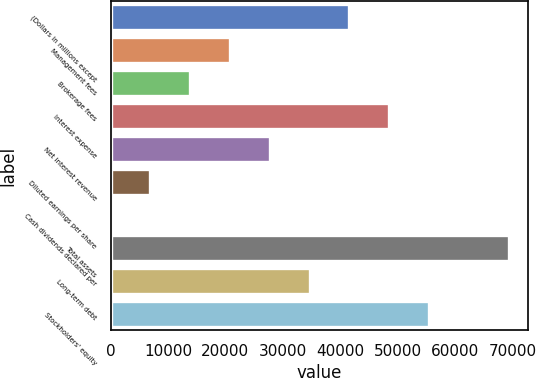<chart> <loc_0><loc_0><loc_500><loc_500><bar_chart><fcel>(Dollars in millions except<fcel>Management fees<fcel>Brokerage fees<fcel>Interest expense<fcel>Net interest revenue<fcel>Diluted earnings per share<fcel>Cash dividends declared per<fcel>Total assets<fcel>Long-term debt<fcel>Stockholders' equity<nl><fcel>41579<fcel>20789.7<fcel>13859.9<fcel>48508.7<fcel>27719.4<fcel>6930.11<fcel>0.34<fcel>69298<fcel>34649.2<fcel>55438.5<nl></chart> 